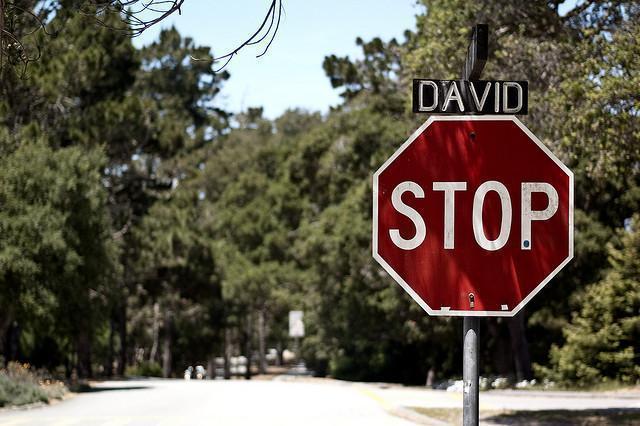What is the name of the street parallel to the stop sign?
Choose the right answer and clarify with the format: 'Answer: answer
Rationale: rationale.'
Options: Chestnut, washington, david, blackberry. Answer: david.
Rationale: The name of the street is on the black sign above the red sign. 